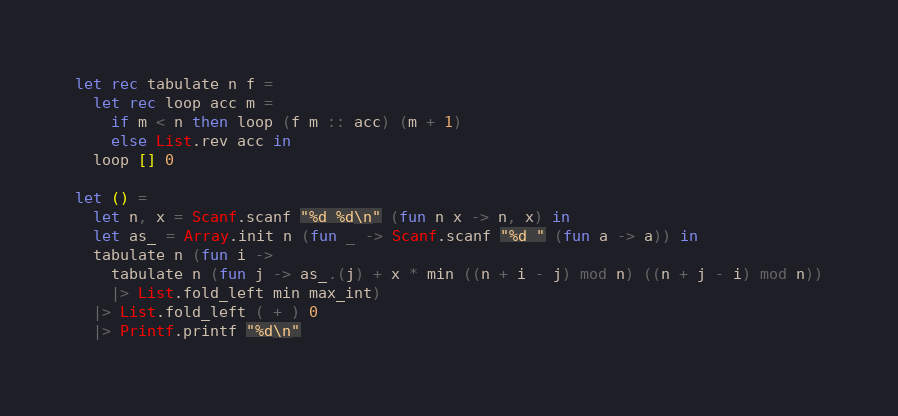<code> <loc_0><loc_0><loc_500><loc_500><_OCaml_>let rec tabulate n f = 
  let rec loop acc m =
    if m < n then loop (f m :: acc) (m + 1)
    else List.rev acc in
  loop [] 0

let () =
  let n, x = Scanf.scanf "%d %d\n" (fun n x -> n, x) in
  let as_ = Array.init n (fun _ -> Scanf.scanf "%d " (fun a -> a)) in
  tabulate n (fun i ->
    tabulate n (fun j -> as_.(j) + x * min ((n + i - j) mod n) ((n + j - i) mod n))
    |> List.fold_left min max_int)
  |> List.fold_left ( + ) 0
  |> Printf.printf "%d\n"
</code> 